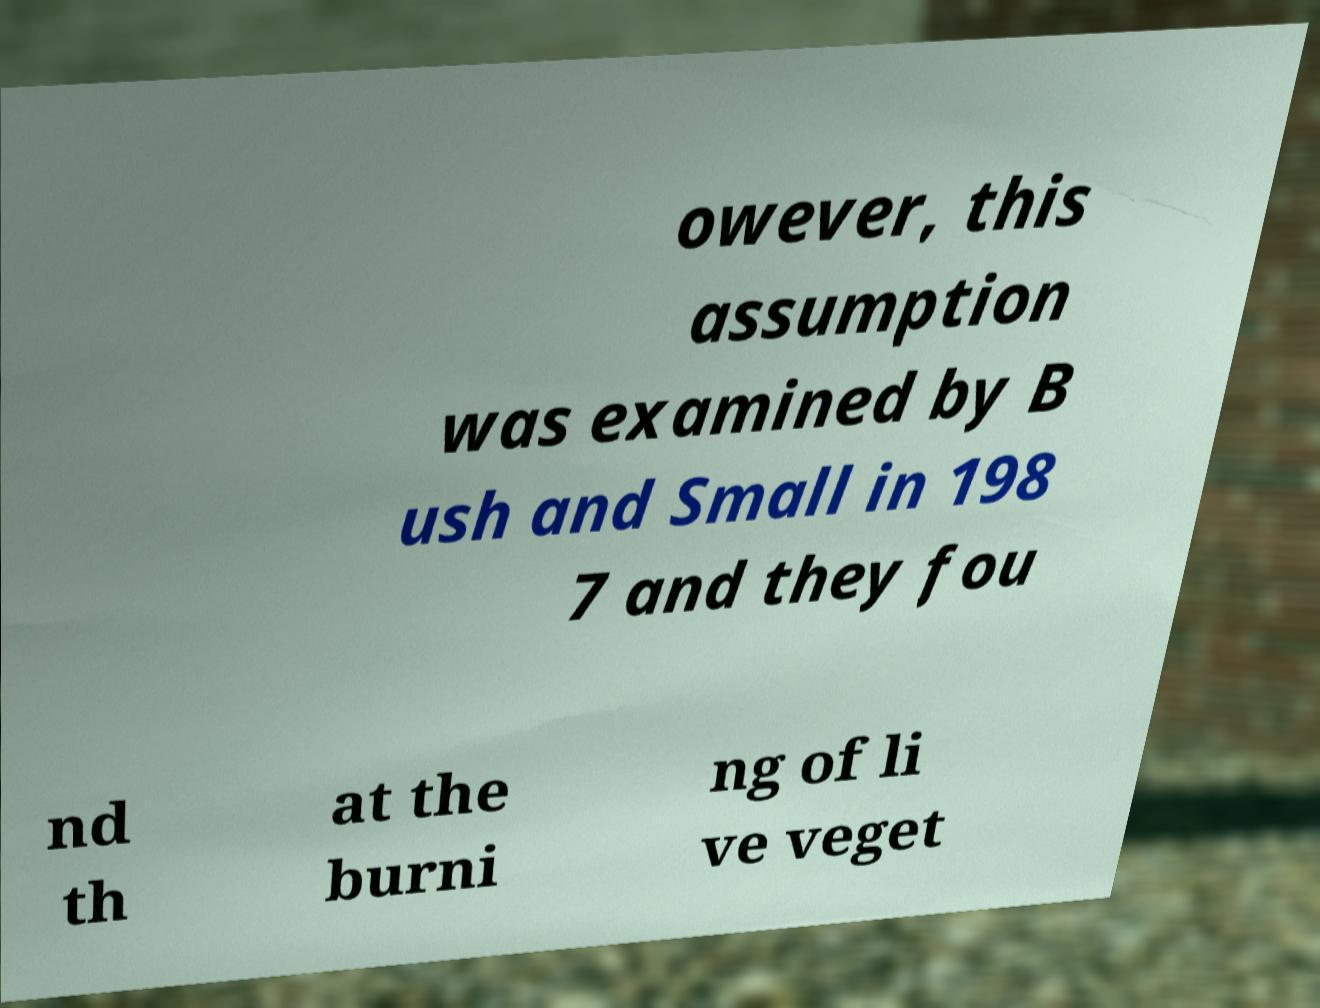There's text embedded in this image that I need extracted. Can you transcribe it verbatim? owever, this assumption was examined by B ush and Small in 198 7 and they fou nd th at the burni ng of li ve veget 